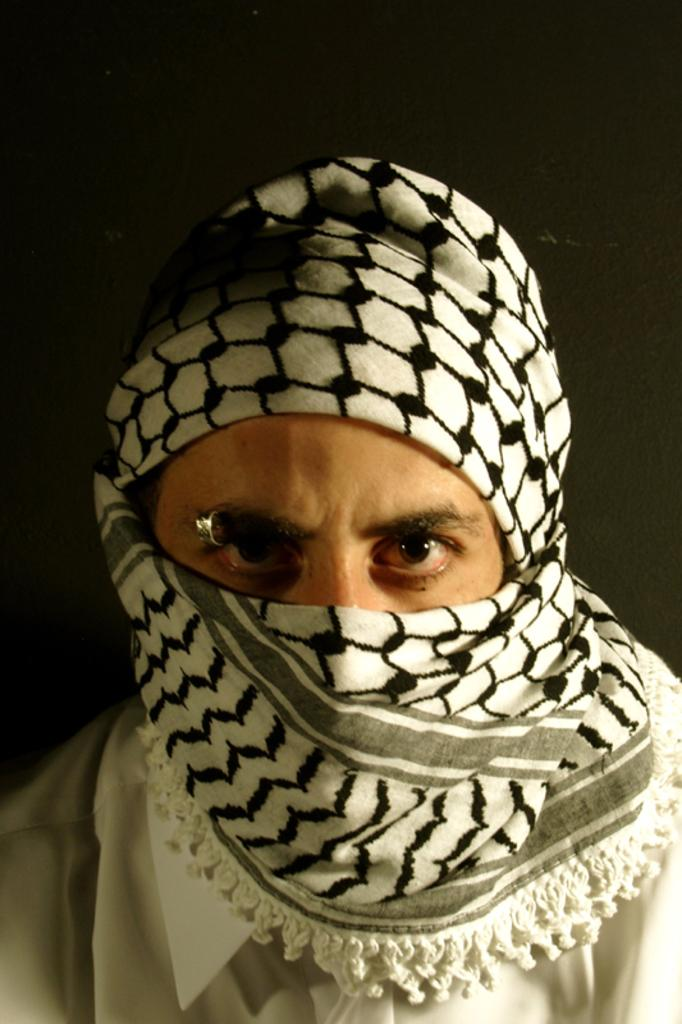What is the main subject of the image? There is a person in the image. How is the person's face and head covered in the image? The person has covered their face and head with a scarf. What type of facial accessory can be seen on the person in the image? The person has a ring on their eyebrow. What is the steepness of the slope in the image? There is no slope present in the image; it features a person with a scarf covering their face and head and an eyebrow ring. How does the calculator help the person in the image? There is no calculator present in the image. 